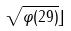<formula> <loc_0><loc_0><loc_500><loc_500>\sqrt { \varphi ( 2 9 ) } \rfloor</formula> 